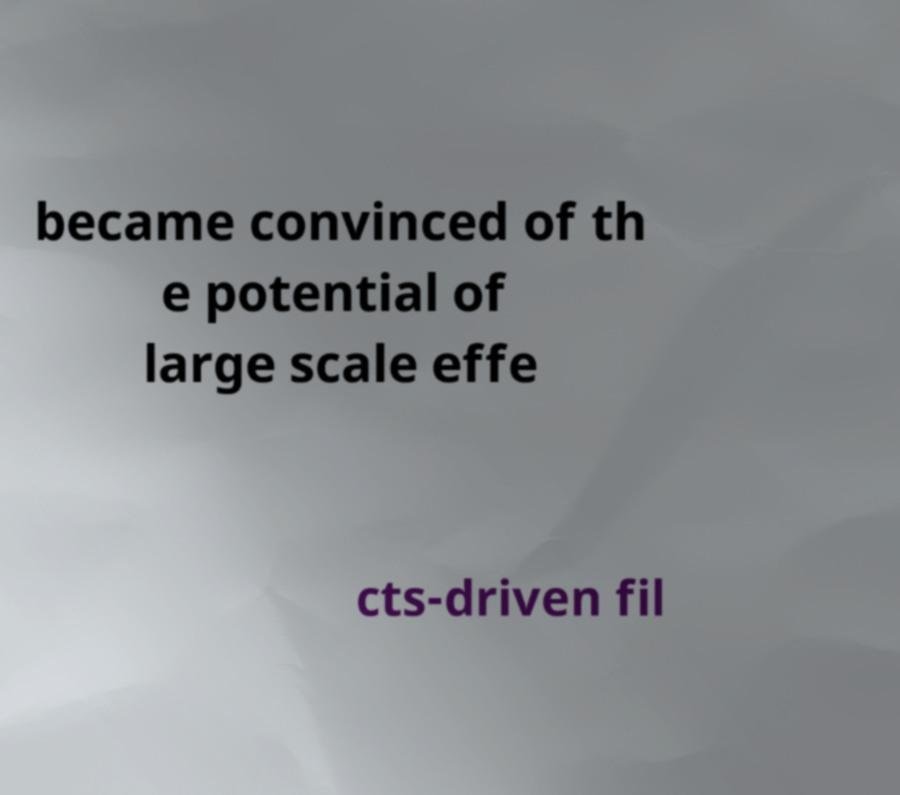Can you accurately transcribe the text from the provided image for me? became convinced of th e potential of large scale effe cts-driven fil 